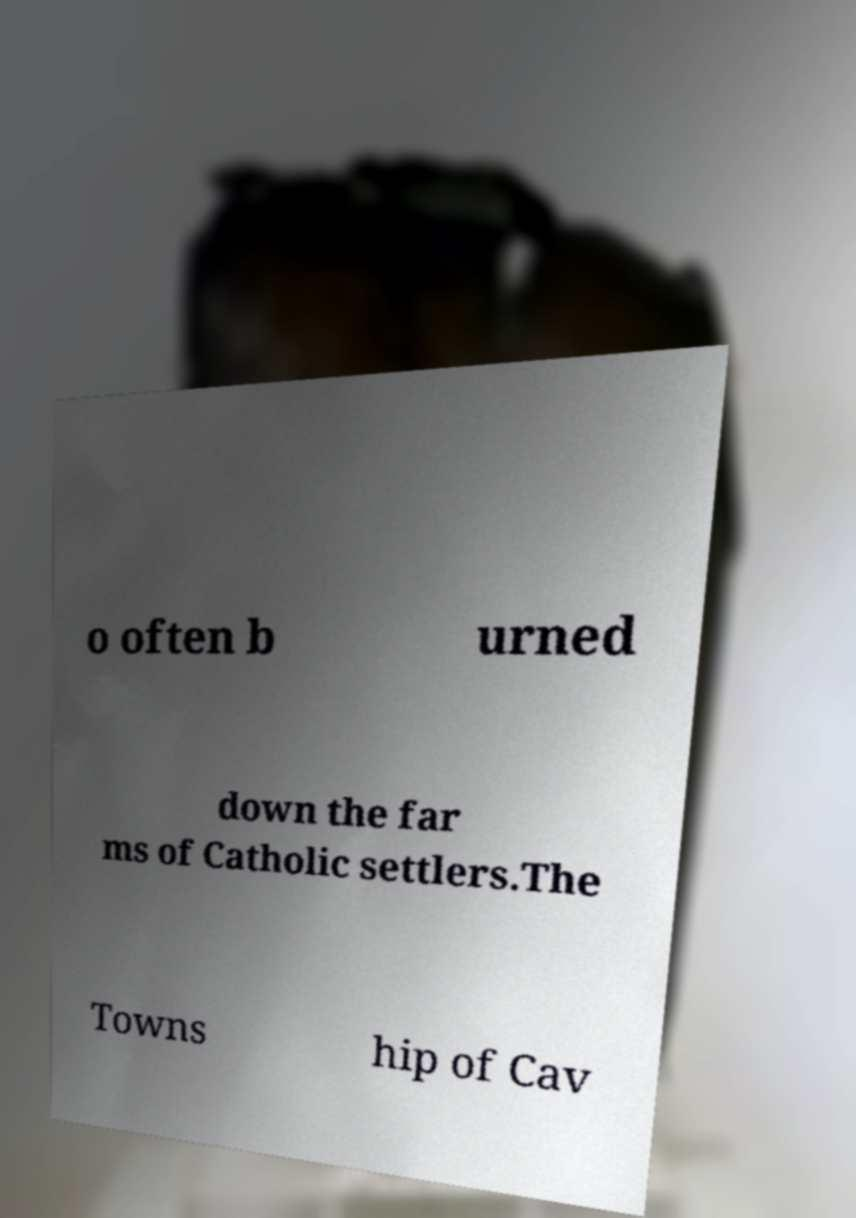I need the written content from this picture converted into text. Can you do that? o often b urned down the far ms of Catholic settlers.The Towns hip of Cav 